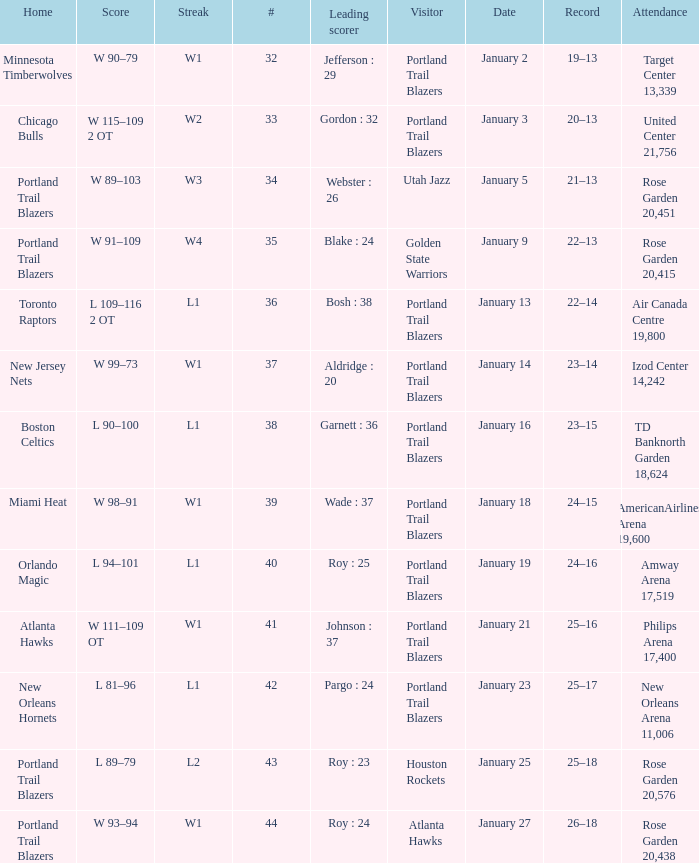What are all the records with a score is w 98–91 24–15. 